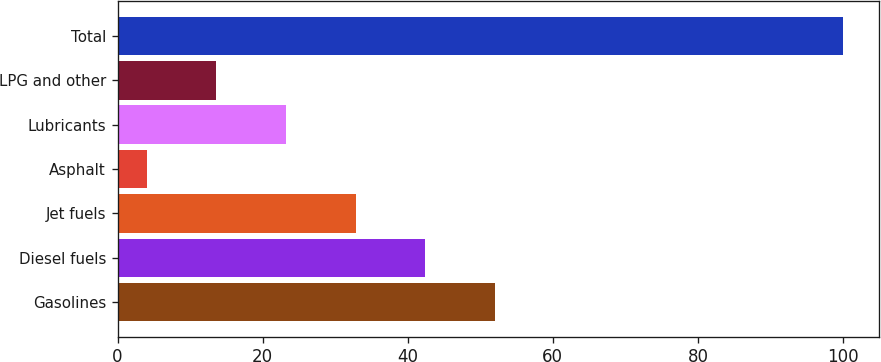<chart> <loc_0><loc_0><loc_500><loc_500><bar_chart><fcel>Gasolines<fcel>Diesel fuels<fcel>Jet fuels<fcel>Asphalt<fcel>Lubricants<fcel>LPG and other<fcel>Total<nl><fcel>52<fcel>42.4<fcel>32.8<fcel>4<fcel>23.2<fcel>13.6<fcel>100<nl></chart> 